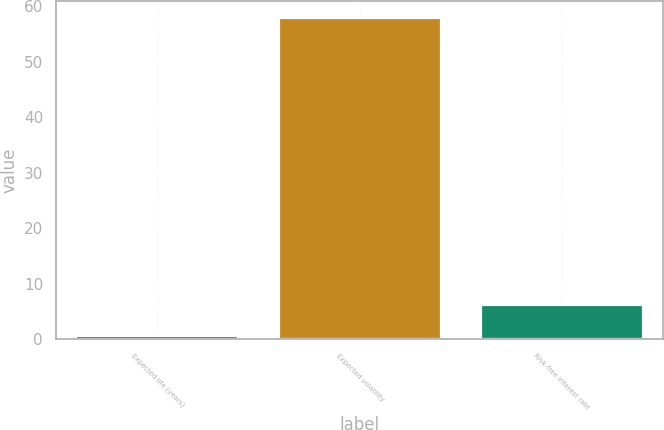Convert chart to OTSL. <chart><loc_0><loc_0><loc_500><loc_500><bar_chart><fcel>Expected life (years)<fcel>Expected volatility<fcel>Risk-free interest rate<nl><fcel>0.5<fcel>58<fcel>6.25<nl></chart> 